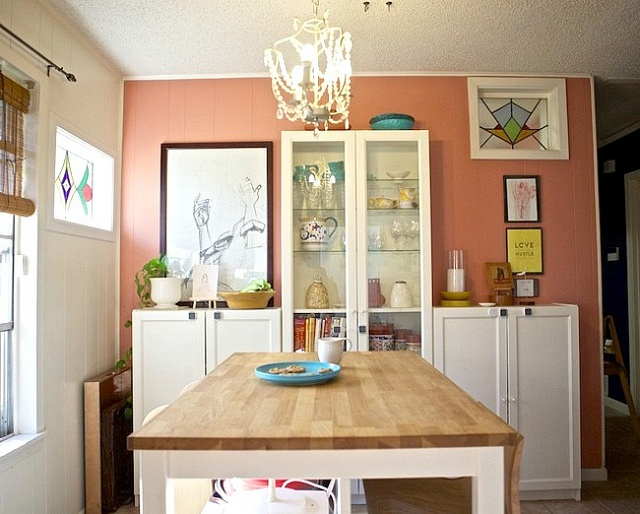Describe the objects in this image and their specific colors. I can see dining table in tan and lightgray tones, vase in tan, darkgray, and beige tones, cup in tan and beige tones, cup in tan, white, and darkgray tones, and bowl in tan and olive tones in this image. 